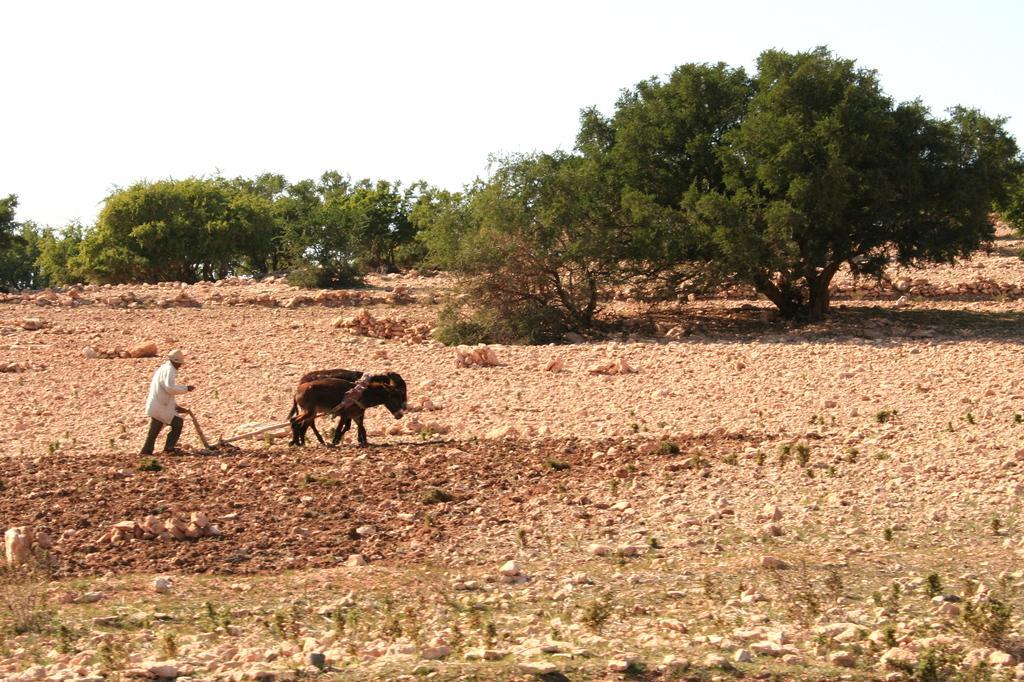Describe this image in one or two sentences. In this image we can see one man with cap holding one wooden object and ploughing a field with two animals. There are some stones on the ground, some trees, some small plants and grass on the ground. At the top there is the sky. 